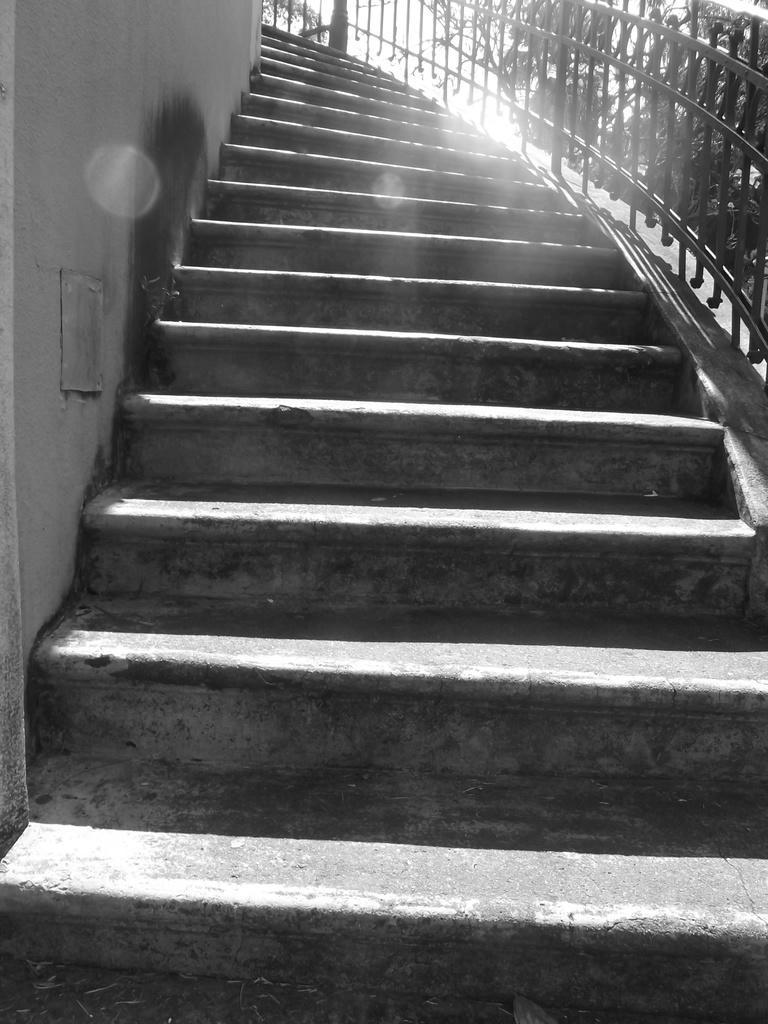Could you give a brief overview of what you see in this image? In this image we can see a staircase, railing, trees and sky. 